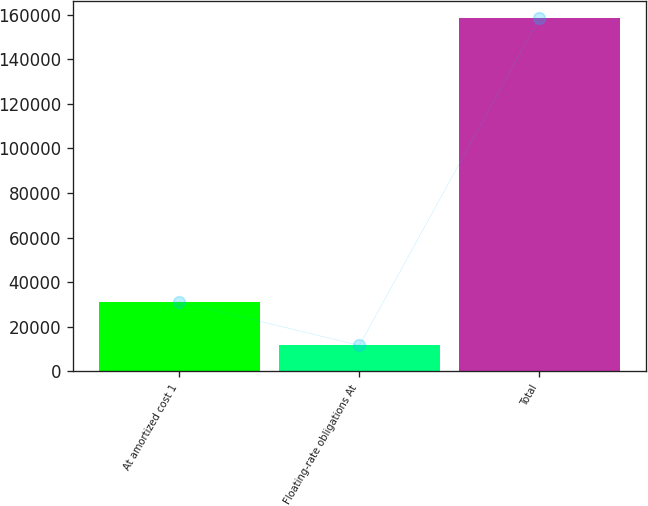Convert chart. <chart><loc_0><loc_0><loc_500><loc_500><bar_chart><fcel>At amortized cost 1<fcel>Floating-rate obligations At<fcel>Total<nl><fcel>31232<fcel>11662<fcel>158311<nl></chart> 